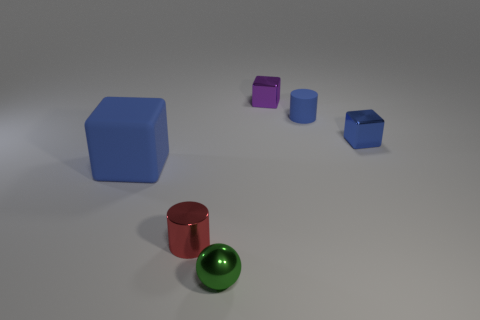There is a blue cylinder; is its size the same as the blue matte object that is on the left side of the shiny cylinder?
Keep it short and to the point. No. What size is the block that is both in front of the tiny blue rubber object and to the left of the tiny rubber cylinder?
Ensure brevity in your answer.  Large. Is there a large gray cylinder that has the same material as the red cylinder?
Provide a short and direct response. No. The tiny purple object is what shape?
Offer a terse response. Cube. Do the blue matte block and the purple shiny thing have the same size?
Make the answer very short. No. What number of other objects are there of the same shape as the tiny red object?
Ensure brevity in your answer.  1. There is a metallic thing that is on the left side of the green sphere; what shape is it?
Offer a terse response. Cylinder. There is a tiny red object that is to the left of the blue metal object; is its shape the same as the matte thing in front of the blue metal cube?
Your answer should be very brief. No. Are there the same number of cylinders that are in front of the large thing and tiny red metal cubes?
Your answer should be very brief. No. Are there any other things that have the same size as the red metal cylinder?
Keep it short and to the point. Yes. 